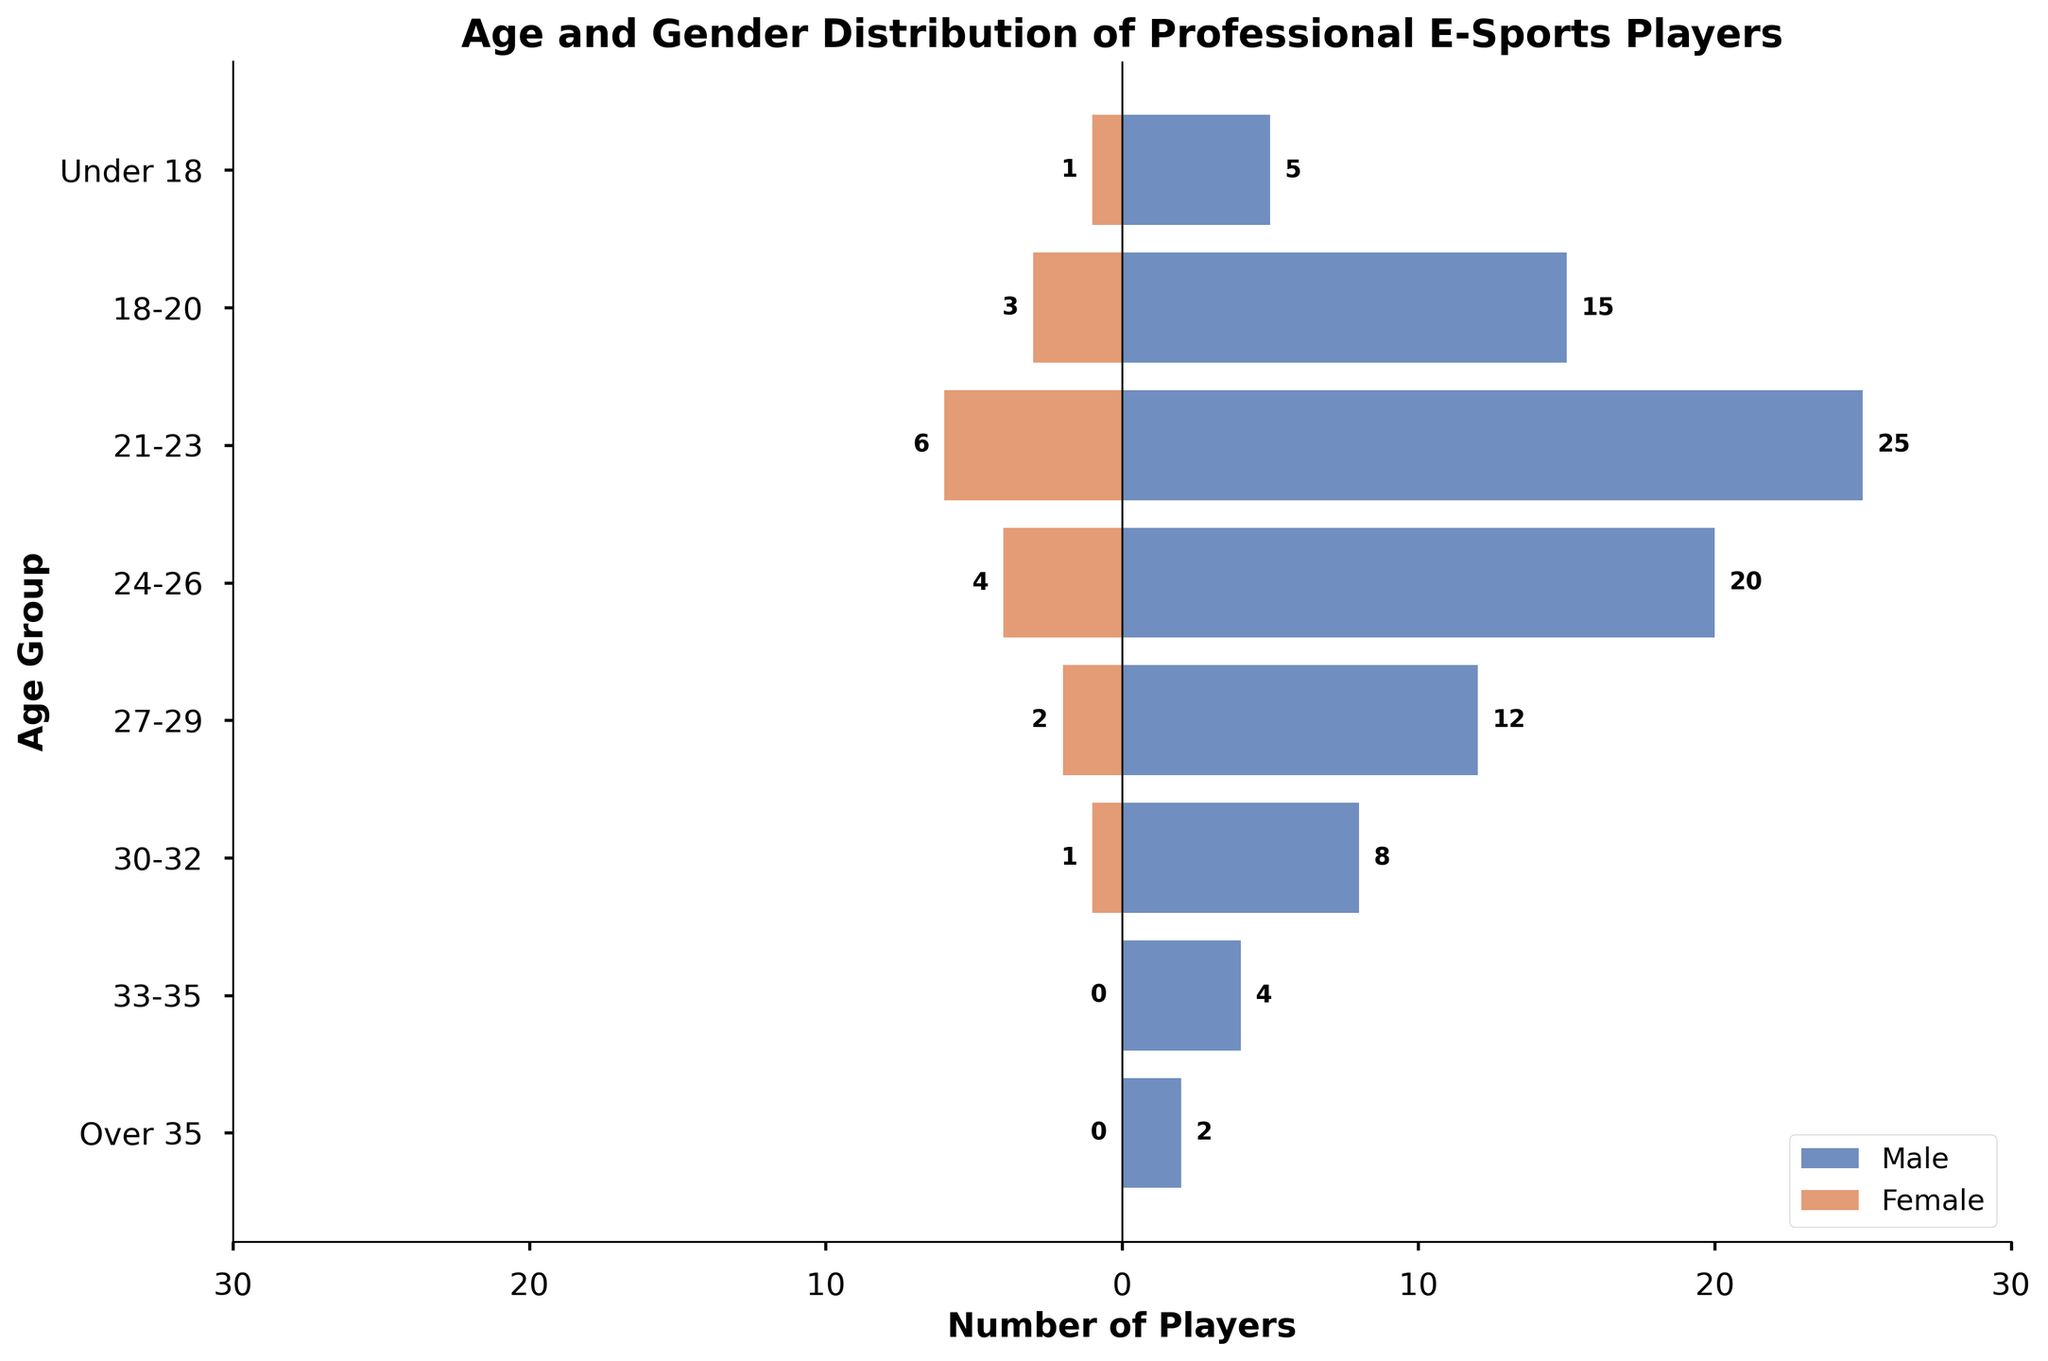Which age group has the highest number of male players? Identify the tallest blue bar on the left side of the plot. The 21-23 age group has the highest number of male players with 25.
Answer: 21-23 What is the total number of female players across all age groups? Convert all female values to positive and sum them up: 1+3+6+4+2+1+0+0 = 17.
Answer: 17 Which age group shows the largest difference between male and female players? Compare the numerical difference for each age group. The 21-23 age group has the largest difference, with 19 more males than females (25 males - 6 females).
Answer: 21-23 What is the total number of players (both male and female) in the 24-26 age group? Add the male and female players in the 24-26 group (20 males + 4 females) = 24.
Answer: 24 Which gender has more players in the 30-32 age group, and by how much? Compare the values for each gender within the 30-32 age group. There are 7 more males than females (8 males - 1 female).
Answer: Male, 7 How many age groups have more than 10 male players? Count the number of age groups where the male bar exceeds 10. Those groups are: 18-20, 21-23, 24-26, and 27-29. So there are 4 groups.
Answer: 4 What is the ratio of male to female players in the 18-20 age group? Calculate the ratio by dividing the number of male players by the number of female players (15 males / 3 females) = 5.
Answer: 5 Which age group has the same number of players for both genders? Look for an age group where male and female bars are equal. There isn't such an age group.
Answer: None In which age group is the number of male players closest to the number of female players? Check each age group and find the smallest difference. The Under 18 age group has the smallest difference with 4 (5 males - 1 female).
Answer: Under 18 